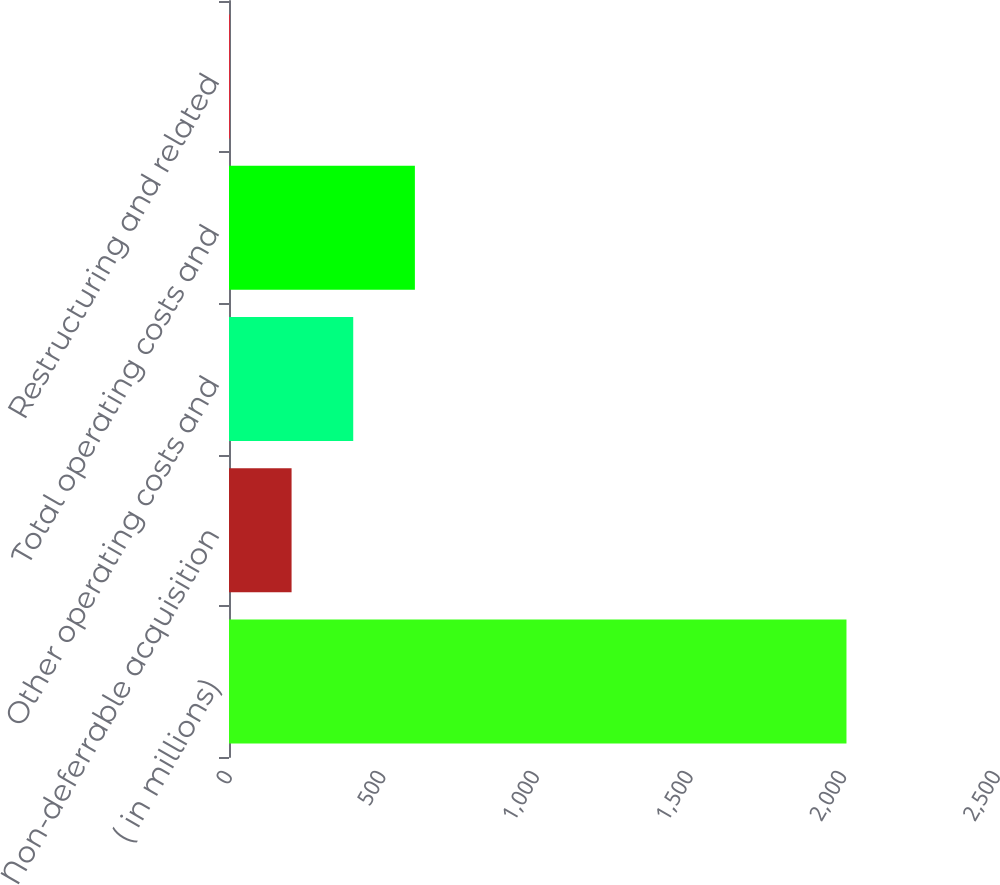Convert chart. <chart><loc_0><loc_0><loc_500><loc_500><bar_chart><fcel>( in millions)<fcel>Non-deferrable acquisition<fcel>Other operating costs and<fcel>Total operating costs and<fcel>Restructuring and related<nl><fcel>2010<fcel>203.7<fcel>404.4<fcel>605.1<fcel>3<nl></chart> 